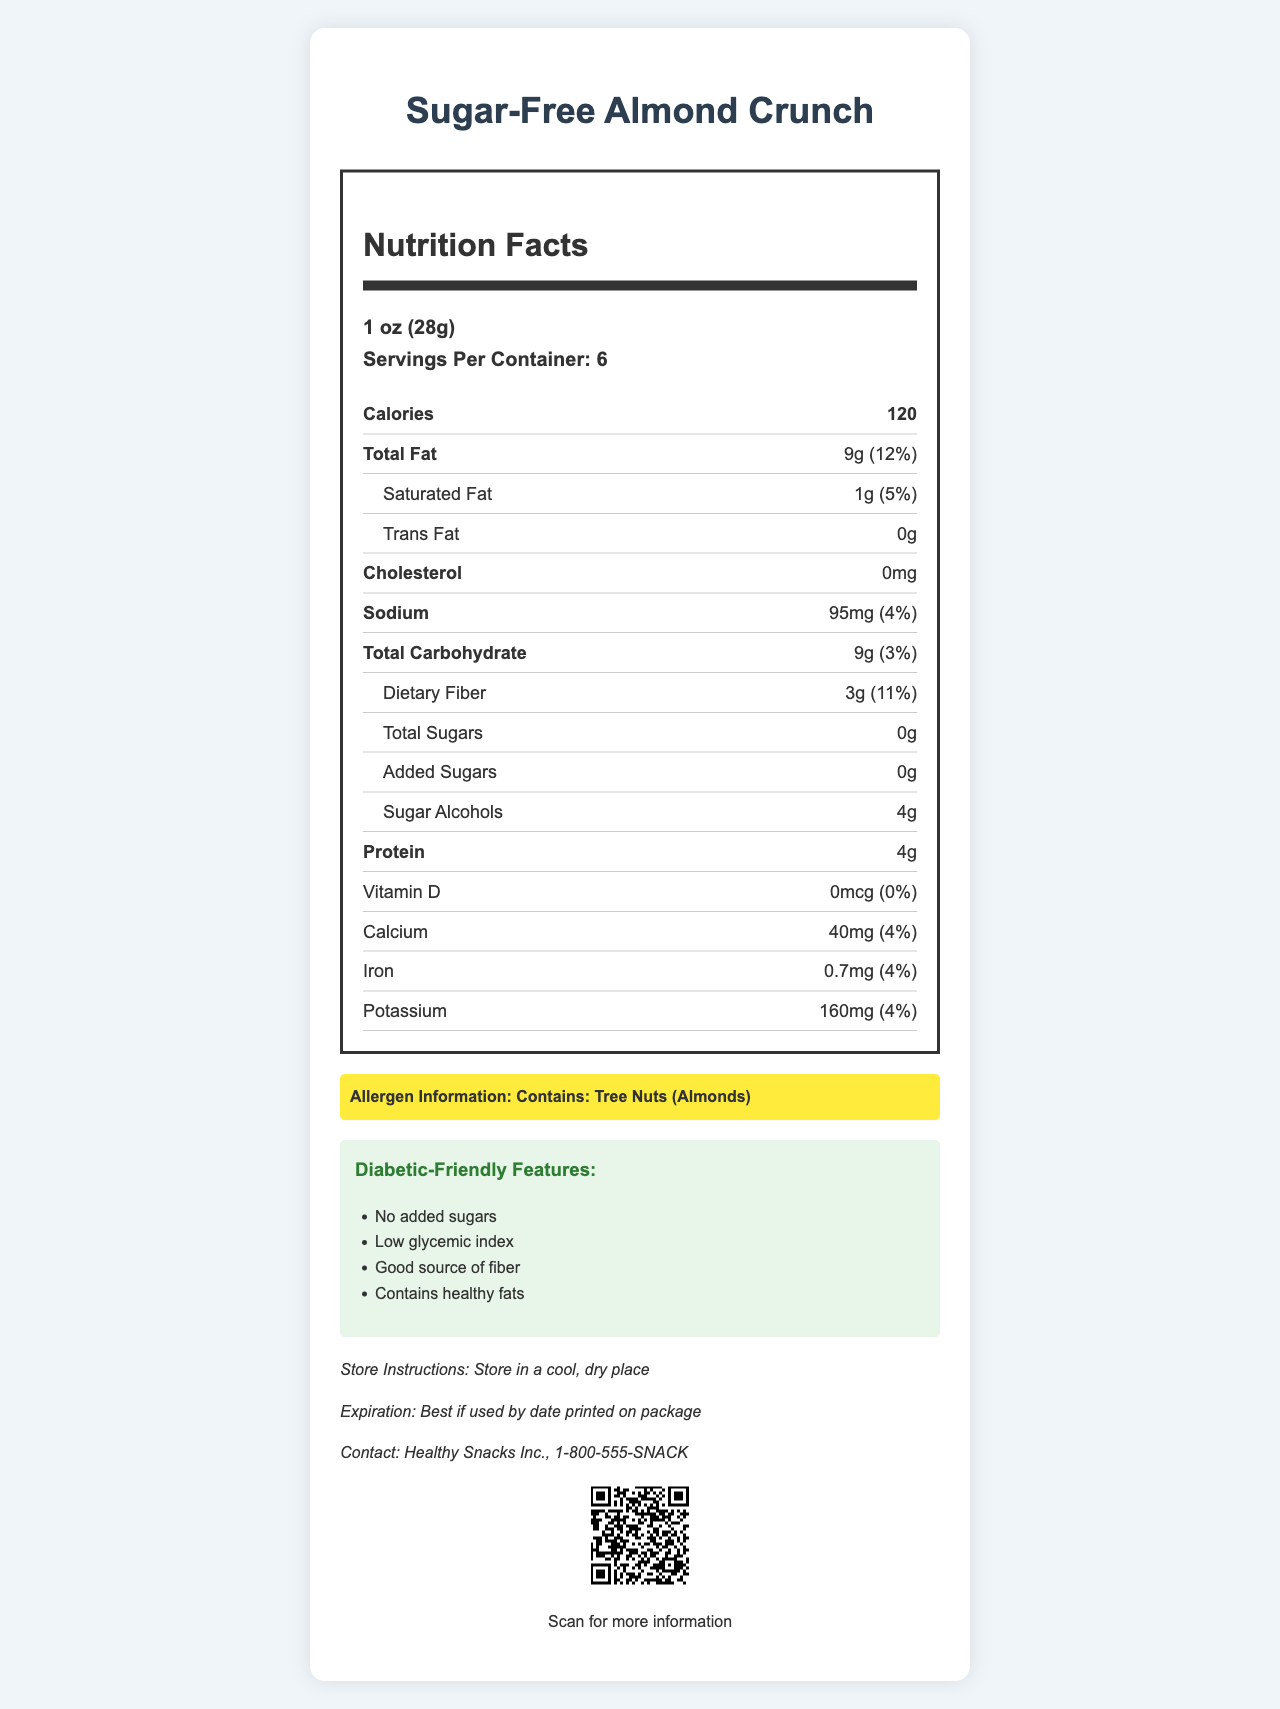what is the serving size? The serving size is mentioned at the top of the Nutrition Facts section under serving information.
Answer: 1 oz (28g) how many servings are there per container? The number of servings per container is listed alongside the serving size in the Nutrition Facts section.
Answer: 6 how much dietary fiber is in one serving? The dietary fiber content per serving is listed under the Total Carbohydrate section in the Nutrition Facts.
Answer: 3g how many calories does one serving of this snack provide? The calorie count per serving is specified prominently in the Calories section of the Nutrition Facts label.
Answer: 120 what is the total amount of fat per serving? The total fat per serving is mentioned towards the top of the Nutrition Facts section, with its daily value percentage.
Answer: 9g does this product contain any cholesterol? The cholesterol content is specified as 0mg in the Nutrition Facts section.
Answer: No what allergens are present in this snack? The Allergen Information section highlights that this snack contains tree nuts, specifically almonds.
Answer: Tree Nuts (Almonds) how much protein is in one serving of this snack? The protein content per serving can be found in the Nutrition Facts section near the bottom.
Answer: 4g which of the following is a feature of this diabetic-friendly snack? A. High Sugars B. Gluten-Free C. Low Glycemic Index The snack is described as having a low glycemic index in the Diabetic-Friendly Features section.
Answer: C how much sodium does one serving contain? A. 50mg B. 75mg C. 95mg D. 100mg The sodium content per serving is listed as 95mg in the Nutrition Facts section.
Answer: C what is the expiration instruction for this product? The expiration instruction states that the product is best if used by the date printed on the package.
Answer: Best if used by date printed on package is there any vitamin D in this snack? The amount of vitamin D is listed as 0mcg in the Nutrition Facts, indicating none is present.
Answer: No does this snack support voice-readable options? The document notes that the snack's information is voice-readable under the Smartphone-Compatible section.
Answer: Yes describe the main information presented in the document The document details the nutritional content, highlights allergens, diabetic-friendly features, contact information, and technological accessibility for the "Sugar-Free Almond Crunch" snack.
Answer: The document provides comprehensive nutritional information about the "Sugar-Free Almond Crunch," including serving size, calories, and nutrient details. It also highlights allergen information, diabetic-friendly features, and additional storage and expiration details. The document is presented in an easy-to-read format with large font, high contrast, and important info in bold, and it includes a QR code to access more information. what is the exact amount of "natural flavors" used in the ingredients? The document lists "natural flavors" as an ingredient but does not specify the exact amount used.
Answer: Not enough information 